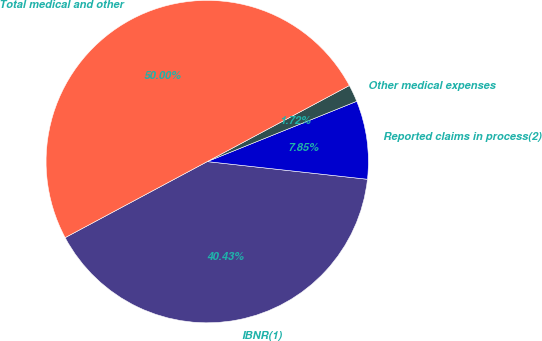<chart> <loc_0><loc_0><loc_500><loc_500><pie_chart><fcel>IBNR(1)<fcel>Reported claims in process(2)<fcel>Other medical expenses<fcel>Total medical and other<nl><fcel>40.43%<fcel>7.85%<fcel>1.72%<fcel>50.0%<nl></chart> 